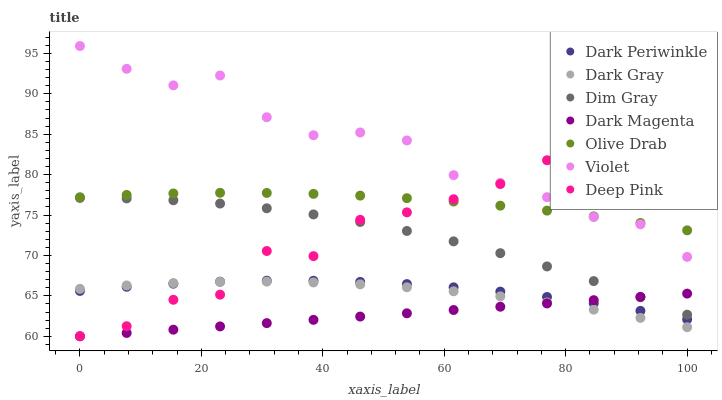Does Dark Magenta have the minimum area under the curve?
Answer yes or no. Yes. Does Violet have the maximum area under the curve?
Answer yes or no. Yes. Does Dark Gray have the minimum area under the curve?
Answer yes or no. No. Does Dark Gray have the maximum area under the curve?
Answer yes or no. No. Is Dark Magenta the smoothest?
Answer yes or no. Yes. Is Deep Pink the roughest?
Answer yes or no. Yes. Is Dark Gray the smoothest?
Answer yes or no. No. Is Dark Gray the roughest?
Answer yes or no. No. Does Dark Magenta have the lowest value?
Answer yes or no. Yes. Does Dark Gray have the lowest value?
Answer yes or no. No. Does Violet have the highest value?
Answer yes or no. Yes. Does Dark Gray have the highest value?
Answer yes or no. No. Is Dark Gray less than Dim Gray?
Answer yes or no. Yes. Is Olive Drab greater than Dim Gray?
Answer yes or no. Yes. Does Deep Pink intersect Dim Gray?
Answer yes or no. Yes. Is Deep Pink less than Dim Gray?
Answer yes or no. No. Is Deep Pink greater than Dim Gray?
Answer yes or no. No. Does Dark Gray intersect Dim Gray?
Answer yes or no. No. 